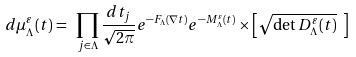Convert formula to latex. <formula><loc_0><loc_0><loc_500><loc_500>d \mu _ { \Lambda } ^ { \varepsilon } ( t ) = \ \prod _ { j \in \Lambda } \frac { d t _ { j } } { \sqrt { 2 \pi } } e ^ { - F _ { \Lambda } ( \nabla t ) } e ^ { - M ^ { \varepsilon } _ { \Lambda } ( t ) } \times \left [ \sqrt { \det D ^ { \varepsilon } _ { \Lambda } ( t ) } \ \right ]</formula> 